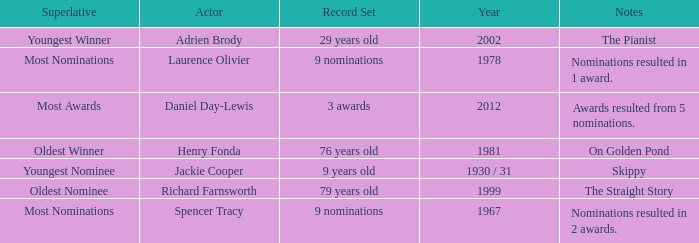What year was the the youngest nominee a winner? 1930 / 31. 